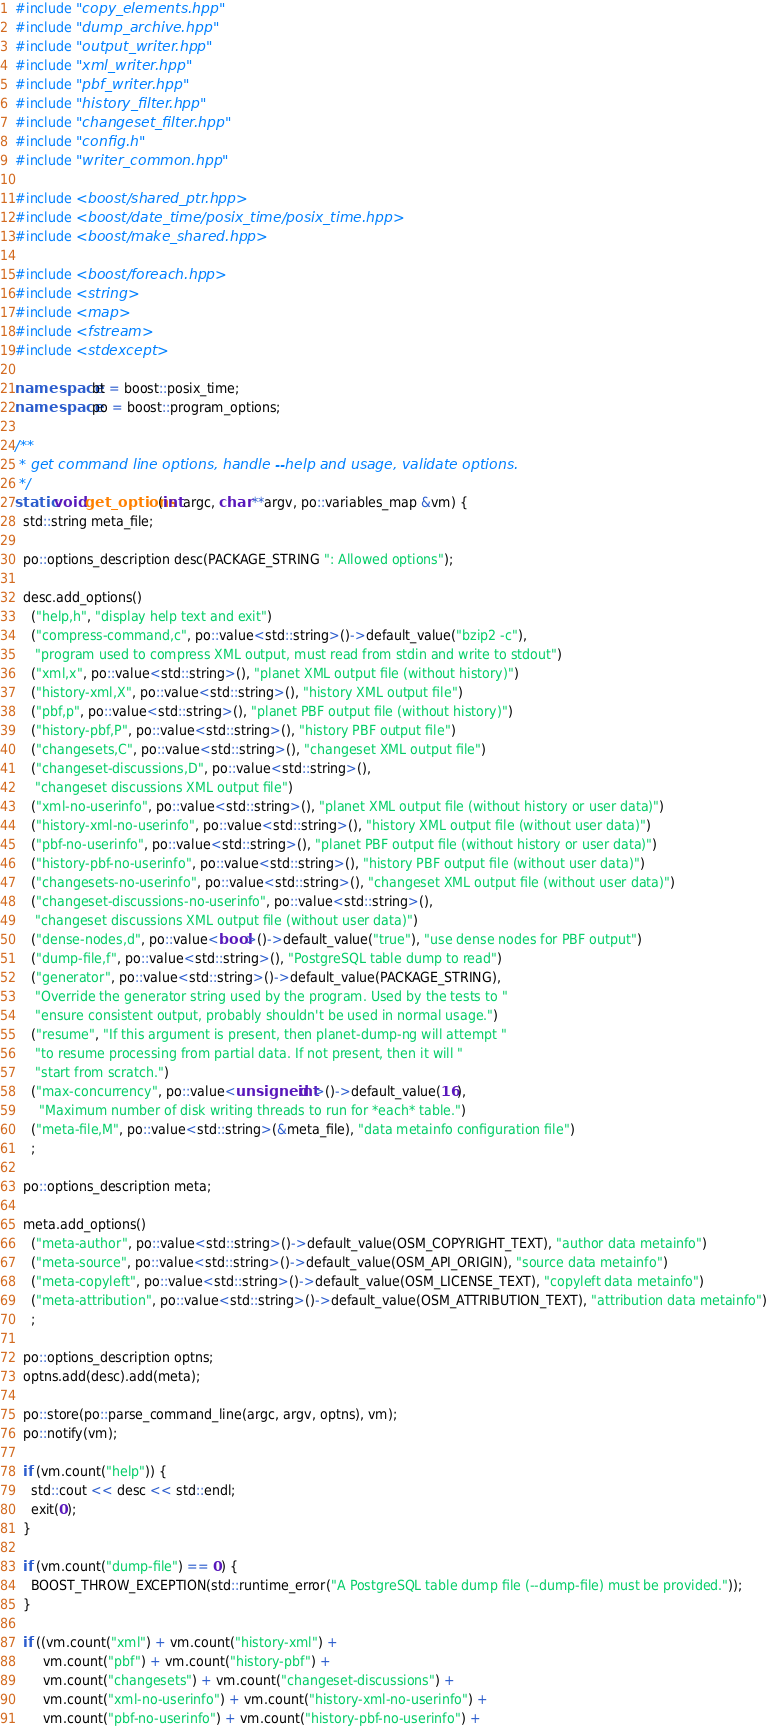<code> <loc_0><loc_0><loc_500><loc_500><_C++_>#include "copy_elements.hpp"
#include "dump_archive.hpp"
#include "output_writer.hpp"
#include "xml_writer.hpp"
#include "pbf_writer.hpp"
#include "history_filter.hpp"
#include "changeset_filter.hpp"
#include "config.h"
#include "writer_common.hpp"

#include <boost/shared_ptr.hpp>
#include <boost/date_time/posix_time/posix_time.hpp>
#include <boost/make_shared.hpp>

#include <boost/foreach.hpp>
#include <string>
#include <map>
#include <fstream>
#include <stdexcept>

namespace bt = boost::posix_time;
namespace po = boost::program_options;

/**
 * get command line options, handle --help and usage, validate options.
 */
static void get_options(int argc, char **argv, po::variables_map &vm) {
  std::string meta_file;

  po::options_description desc(PACKAGE_STRING ": Allowed options");

  desc.add_options()
    ("help,h", "display help text and exit")
    ("compress-command,c", po::value<std::string>()->default_value("bzip2 -c"),
     "program used to compress XML output, must read from stdin and write to stdout")
    ("xml,x", po::value<std::string>(), "planet XML output file (without history)")
    ("history-xml,X", po::value<std::string>(), "history XML output file")
    ("pbf,p", po::value<std::string>(), "planet PBF output file (without history)")
    ("history-pbf,P", po::value<std::string>(), "history PBF output file")
    ("changesets,C", po::value<std::string>(), "changeset XML output file")
    ("changeset-discussions,D", po::value<std::string>(),
     "changeset discussions XML output file")
    ("xml-no-userinfo", po::value<std::string>(), "planet XML output file (without history or user data)")
    ("history-xml-no-userinfo", po::value<std::string>(), "history XML output file (without user data)")
    ("pbf-no-userinfo", po::value<std::string>(), "planet PBF output file (without history or user data)")
    ("history-pbf-no-userinfo", po::value<std::string>(), "history PBF output file (without user data)")
    ("changesets-no-userinfo", po::value<std::string>(), "changeset XML output file (without user data)")
    ("changeset-discussions-no-userinfo", po::value<std::string>(),
     "changeset discussions XML output file (without user data)")
    ("dense-nodes,d", po::value<bool>()->default_value("true"), "use dense nodes for PBF output")
    ("dump-file,f", po::value<std::string>(), "PostgreSQL table dump to read")
    ("generator", po::value<std::string>()->default_value(PACKAGE_STRING),
     "Override the generator string used by the program. Used by the tests to "
     "ensure consistent output, probably shouldn't be used in normal usage.")
    ("resume", "If this argument is present, then planet-dump-ng will attempt "
     "to resume processing from partial data. If not present, then it will "
     "start from scratch.")
    ("max-concurrency", po::value<unsigned int>()->default_value(16),
      "Maximum number of disk writing threads to run for *each* table.")
    ("meta-file,M", po::value<std::string>(&meta_file), "data metainfo configuration file")
    ;
    
  po::options_description meta;
  
  meta.add_options()
    ("meta-author", po::value<std::string>()->default_value(OSM_COPYRIGHT_TEXT), "author data metainfo")
    ("meta-source", po::value<std::string>()->default_value(OSM_API_ORIGIN), "source data metainfo")
    ("meta-copyleft", po::value<std::string>()->default_value(OSM_LICENSE_TEXT), "copyleft data metainfo")
    ("meta-attribution", po::value<std::string>()->default_value(OSM_ATTRIBUTION_TEXT), "attribution data metainfo")
    ;
  
  po::options_description optns;
  optns.add(desc).add(meta);

  po::store(po::parse_command_line(argc, argv, optns), vm);
  po::notify(vm);

  if (vm.count("help")) {
    std::cout << desc << std::endl;
    exit(0);
  }

  if (vm.count("dump-file") == 0) {
    BOOST_THROW_EXCEPTION(std::runtime_error("A PostgreSQL table dump file (--dump-file) must be provided."));
  }

  if ((vm.count("xml") + vm.count("history-xml") +
       vm.count("pbf") + vm.count("history-pbf") + 
       vm.count("changesets") + vm.count("changeset-discussions") +
       vm.count("xml-no-userinfo") + vm.count("history-xml-no-userinfo") +
       vm.count("pbf-no-userinfo") + vm.count("history-pbf-no-userinfo") + </code> 